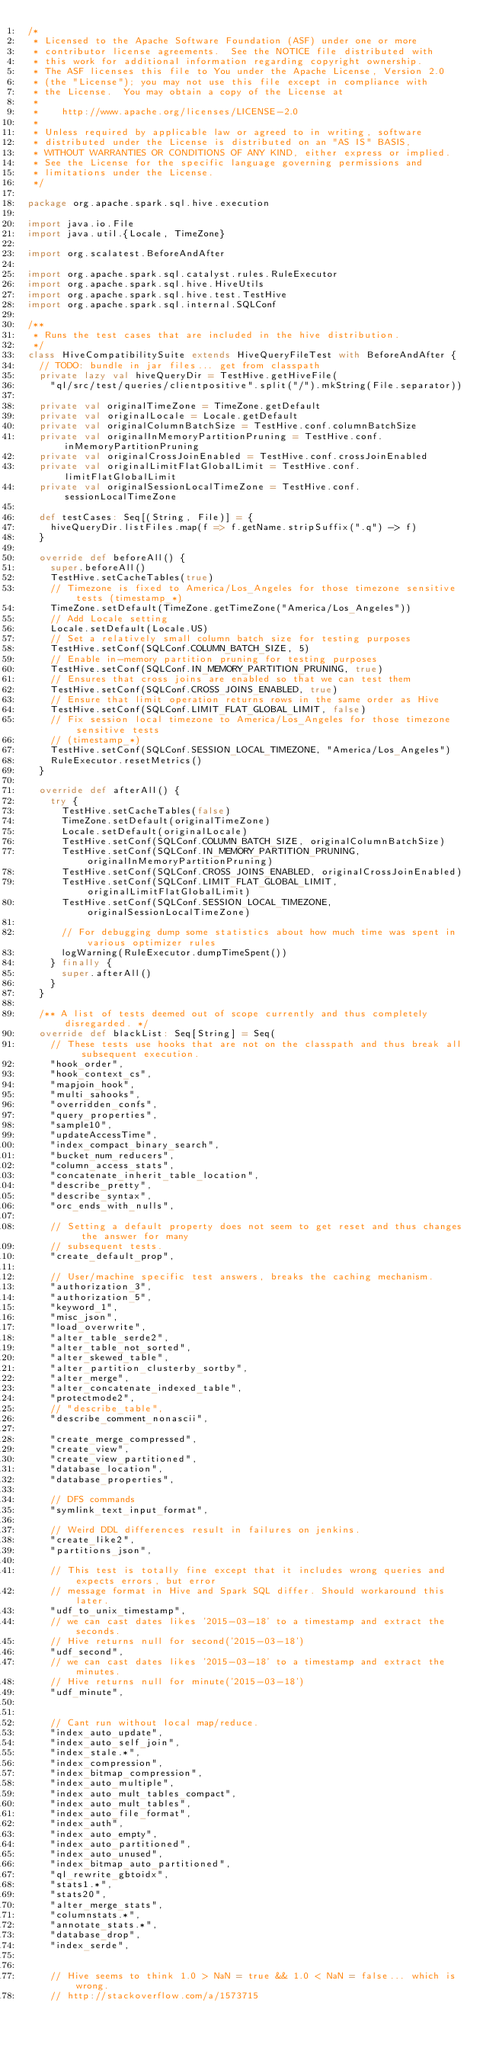Convert code to text. <code><loc_0><loc_0><loc_500><loc_500><_Scala_>/*
 * Licensed to the Apache Software Foundation (ASF) under one or more
 * contributor license agreements.  See the NOTICE file distributed with
 * this work for additional information regarding copyright ownership.
 * The ASF licenses this file to You under the Apache License, Version 2.0
 * (the "License"); you may not use this file except in compliance with
 * the License.  You may obtain a copy of the License at
 *
 *    http://www.apache.org/licenses/LICENSE-2.0
 *
 * Unless required by applicable law or agreed to in writing, software
 * distributed under the License is distributed on an "AS IS" BASIS,
 * WITHOUT WARRANTIES OR CONDITIONS OF ANY KIND, either express or implied.
 * See the License for the specific language governing permissions and
 * limitations under the License.
 */

package org.apache.spark.sql.hive.execution

import java.io.File
import java.util.{Locale, TimeZone}

import org.scalatest.BeforeAndAfter

import org.apache.spark.sql.catalyst.rules.RuleExecutor
import org.apache.spark.sql.hive.HiveUtils
import org.apache.spark.sql.hive.test.TestHive
import org.apache.spark.sql.internal.SQLConf

/**
 * Runs the test cases that are included in the hive distribution.
 */
class HiveCompatibilitySuite extends HiveQueryFileTest with BeforeAndAfter {
  // TODO: bundle in jar files... get from classpath
  private lazy val hiveQueryDir = TestHive.getHiveFile(
    "ql/src/test/queries/clientpositive".split("/").mkString(File.separator))

  private val originalTimeZone = TimeZone.getDefault
  private val originalLocale = Locale.getDefault
  private val originalColumnBatchSize = TestHive.conf.columnBatchSize
  private val originalInMemoryPartitionPruning = TestHive.conf.inMemoryPartitionPruning
  private val originalCrossJoinEnabled = TestHive.conf.crossJoinEnabled
  private val originalLimitFlatGlobalLimit = TestHive.conf.limitFlatGlobalLimit
  private val originalSessionLocalTimeZone = TestHive.conf.sessionLocalTimeZone

  def testCases: Seq[(String, File)] = {
    hiveQueryDir.listFiles.map(f => f.getName.stripSuffix(".q") -> f)
  }

  override def beforeAll() {
    super.beforeAll()
    TestHive.setCacheTables(true)
    // Timezone is fixed to America/Los_Angeles for those timezone sensitive tests (timestamp_*)
    TimeZone.setDefault(TimeZone.getTimeZone("America/Los_Angeles"))
    // Add Locale setting
    Locale.setDefault(Locale.US)
    // Set a relatively small column batch size for testing purposes
    TestHive.setConf(SQLConf.COLUMN_BATCH_SIZE, 5)
    // Enable in-memory partition pruning for testing purposes
    TestHive.setConf(SQLConf.IN_MEMORY_PARTITION_PRUNING, true)
    // Ensures that cross joins are enabled so that we can test them
    TestHive.setConf(SQLConf.CROSS_JOINS_ENABLED, true)
    // Ensure that limit operation returns rows in the same order as Hive
    TestHive.setConf(SQLConf.LIMIT_FLAT_GLOBAL_LIMIT, false)
    // Fix session local timezone to America/Los_Angeles for those timezone sensitive tests
    // (timestamp_*)
    TestHive.setConf(SQLConf.SESSION_LOCAL_TIMEZONE, "America/Los_Angeles")
    RuleExecutor.resetMetrics()
  }

  override def afterAll() {
    try {
      TestHive.setCacheTables(false)
      TimeZone.setDefault(originalTimeZone)
      Locale.setDefault(originalLocale)
      TestHive.setConf(SQLConf.COLUMN_BATCH_SIZE, originalColumnBatchSize)
      TestHive.setConf(SQLConf.IN_MEMORY_PARTITION_PRUNING, originalInMemoryPartitionPruning)
      TestHive.setConf(SQLConf.CROSS_JOINS_ENABLED, originalCrossJoinEnabled)
      TestHive.setConf(SQLConf.LIMIT_FLAT_GLOBAL_LIMIT, originalLimitFlatGlobalLimit)
      TestHive.setConf(SQLConf.SESSION_LOCAL_TIMEZONE, originalSessionLocalTimeZone)

      // For debugging dump some statistics about how much time was spent in various optimizer rules
      logWarning(RuleExecutor.dumpTimeSpent())
    } finally {
      super.afterAll()
    }
  }

  /** A list of tests deemed out of scope currently and thus completely disregarded. */
  override def blackList: Seq[String] = Seq(
    // These tests use hooks that are not on the classpath and thus break all subsequent execution.
    "hook_order",
    "hook_context_cs",
    "mapjoin_hook",
    "multi_sahooks",
    "overridden_confs",
    "query_properties",
    "sample10",
    "updateAccessTime",
    "index_compact_binary_search",
    "bucket_num_reducers",
    "column_access_stats",
    "concatenate_inherit_table_location",
    "describe_pretty",
    "describe_syntax",
    "orc_ends_with_nulls",

    // Setting a default property does not seem to get reset and thus changes the answer for many
    // subsequent tests.
    "create_default_prop",

    // User/machine specific test answers, breaks the caching mechanism.
    "authorization_3",
    "authorization_5",
    "keyword_1",
    "misc_json",
    "load_overwrite",
    "alter_table_serde2",
    "alter_table_not_sorted",
    "alter_skewed_table",
    "alter_partition_clusterby_sortby",
    "alter_merge",
    "alter_concatenate_indexed_table",
    "protectmode2",
    // "describe_table",
    "describe_comment_nonascii",

    "create_merge_compressed",
    "create_view",
    "create_view_partitioned",
    "database_location",
    "database_properties",

    // DFS commands
    "symlink_text_input_format",

    // Weird DDL differences result in failures on jenkins.
    "create_like2",
    "partitions_json",

    // This test is totally fine except that it includes wrong queries and expects errors, but error
    // message format in Hive and Spark SQL differ. Should workaround this later.
    "udf_to_unix_timestamp",
    // we can cast dates likes '2015-03-18' to a timestamp and extract the seconds.
    // Hive returns null for second('2015-03-18')
    "udf_second",
    // we can cast dates likes '2015-03-18' to a timestamp and extract the minutes.
    // Hive returns null for minute('2015-03-18')
    "udf_minute",


    // Cant run without local map/reduce.
    "index_auto_update",
    "index_auto_self_join",
    "index_stale.*",
    "index_compression",
    "index_bitmap_compression",
    "index_auto_multiple",
    "index_auto_mult_tables_compact",
    "index_auto_mult_tables",
    "index_auto_file_format",
    "index_auth",
    "index_auto_empty",
    "index_auto_partitioned",
    "index_auto_unused",
    "index_bitmap_auto_partitioned",
    "ql_rewrite_gbtoidx",
    "stats1.*",
    "stats20",
    "alter_merge_stats",
    "columnstats.*",
    "annotate_stats.*",
    "database_drop",
    "index_serde",


    // Hive seems to think 1.0 > NaN = true && 1.0 < NaN = false... which is wrong.
    // http://stackoverflow.com/a/1573715</code> 